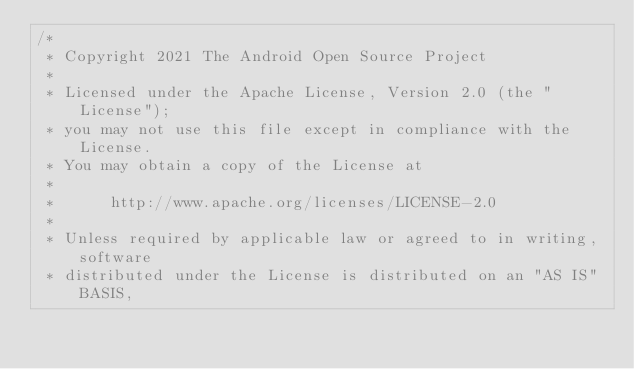<code> <loc_0><loc_0><loc_500><loc_500><_Kotlin_>/*
 * Copyright 2021 The Android Open Source Project
 *
 * Licensed under the Apache License, Version 2.0 (the "License");
 * you may not use this file except in compliance with the License.
 * You may obtain a copy of the License at
 *
 *      http://www.apache.org/licenses/LICENSE-2.0
 *
 * Unless required by applicable law or agreed to in writing, software
 * distributed under the License is distributed on an "AS IS" BASIS,</code> 